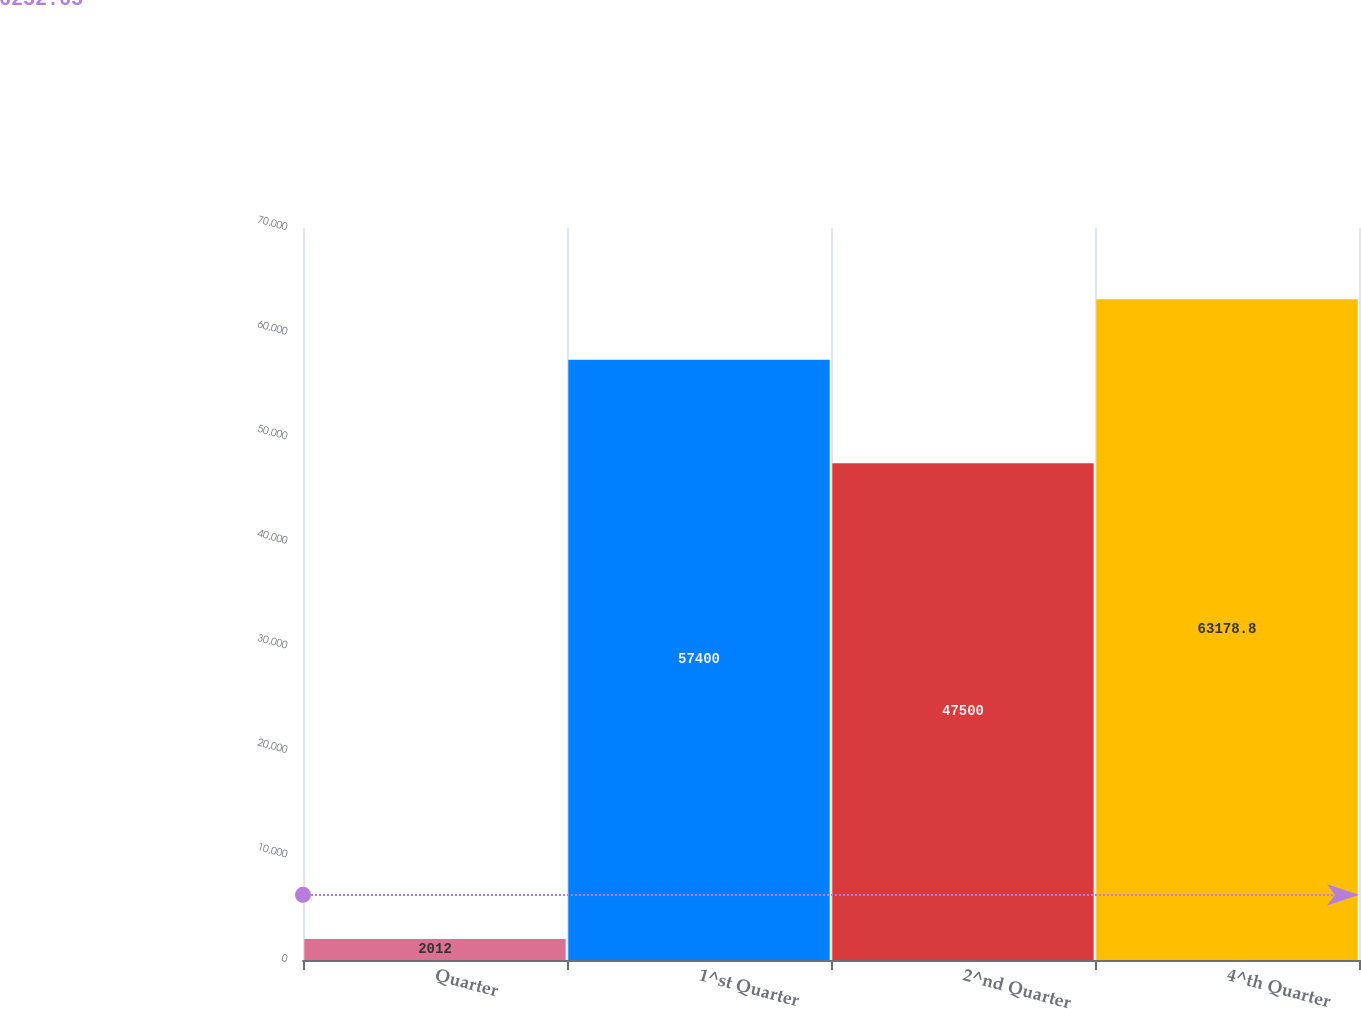Convert chart to OTSL. <chart><loc_0><loc_0><loc_500><loc_500><bar_chart><fcel>Quarter<fcel>1^st Quarter<fcel>2^nd Quarter<fcel>4^th Quarter<nl><fcel>2012<fcel>57400<fcel>47500<fcel>63178.8<nl></chart> 